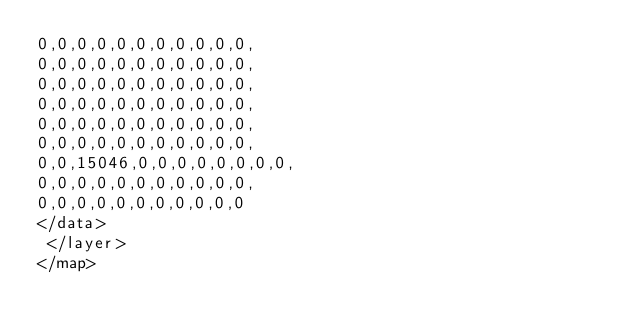Convert code to text. <code><loc_0><loc_0><loc_500><loc_500><_XML_>0,0,0,0,0,0,0,0,0,0,0,
0,0,0,0,0,0,0,0,0,0,0,
0,0,0,0,0,0,0,0,0,0,0,
0,0,0,0,0,0,0,0,0,0,0,
0,0,0,0,0,0,0,0,0,0,0,
0,0,0,0,0,0,0,0,0,0,0,
0,0,15046,0,0,0,0,0,0,0,0,
0,0,0,0,0,0,0,0,0,0,0,
0,0,0,0,0,0,0,0,0,0,0
</data>
 </layer>
</map>
</code> 